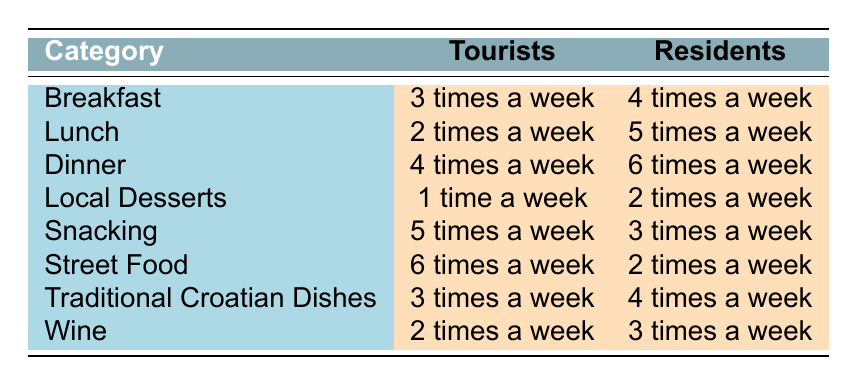What is the frequency of tourists consuming lunch in Zagreb? According to the table, the frequency of tourists consuming lunch in Zagreb is specified as "2 times a week."
Answer: 2 times a week How many times a week do residents consume breakfast compared to tourists? The table states that residents consume breakfast "4 times a week" while tourists consume it "3 times a week," showing that residents consume breakfast 1 time more per week than tourists.
Answer: 1 time more Is the frequency of street food consumption by tourists higher than that of residents? The table shows that tourists consume street food "6 times a week" and residents consume it "2 times a week." Since 6 is greater than 2, the statement is true.
Answer: Yes What is the total frequency of snacking by tourists and residents combined? To find the total frequency of snacking by both groups, we add the tourists' frequency ("5 times a week") and the residents' frequency ("3 times a week"). This results in 5 + 3 = 8 times a week.
Answer: 8 times a week What is the difference in the frequency of wine consumption between residents and tourists? The table states that residents consume wine "3 times a week" while tourists consume it "2 times a week." The difference is calculated by subtracting the tourists' frequency from the residents', which is 3 - 2 = 1 time.
Answer: 1 time Do tourists consume local desserts more often than residents? According to the table, tourists consume local desserts "1 time a week" while residents consume it "2 times a week." Since 1 is less than 2, the statement is false.
Answer: No Which meal category shows the highest frequency of consumption by tourists? Referring to the table, the highest frequency of consumption by tourists is "6 times a week" for street food, which is greater than all other categories.
Answer: Street Food What is the average frequency of traditional Croatian dishes consumed by both tourists and residents? To calculate the average frequency for traditional Croatian dishes, we add the tourists' frequency ("3 times a week") and the residents' frequency ("4 times a week"), resulting in 3 + 4 = 7 times, and then divide by 2 since there are two groups: 7 / 2 = 3.5 times a week.
Answer: 3.5 times a week 